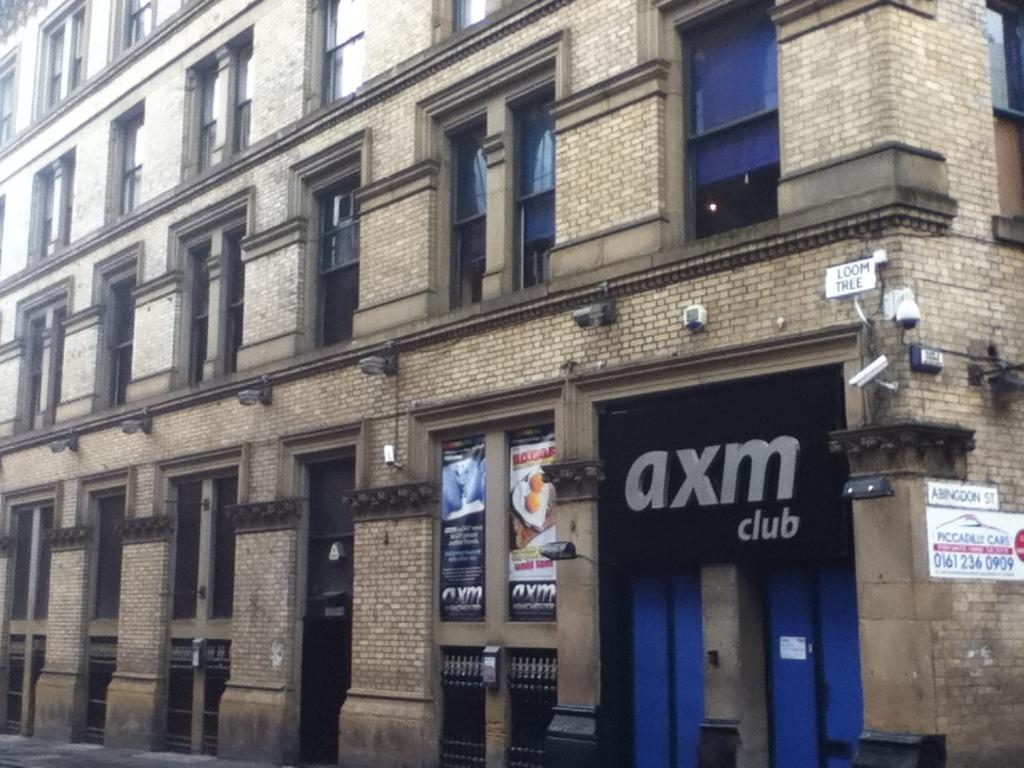What type of establishment is depicted in the image? The image appears to depict a store. What can be seen on the walls of the store? There are posters visible in the image. What is the closest structure to the viewer in the image? There is a building in the foreground of the image. Can you see any arguments taking place between customers in the image? There is no indication of any arguments or conflicts in the image; it simply depicts a store with posters on the walls. 